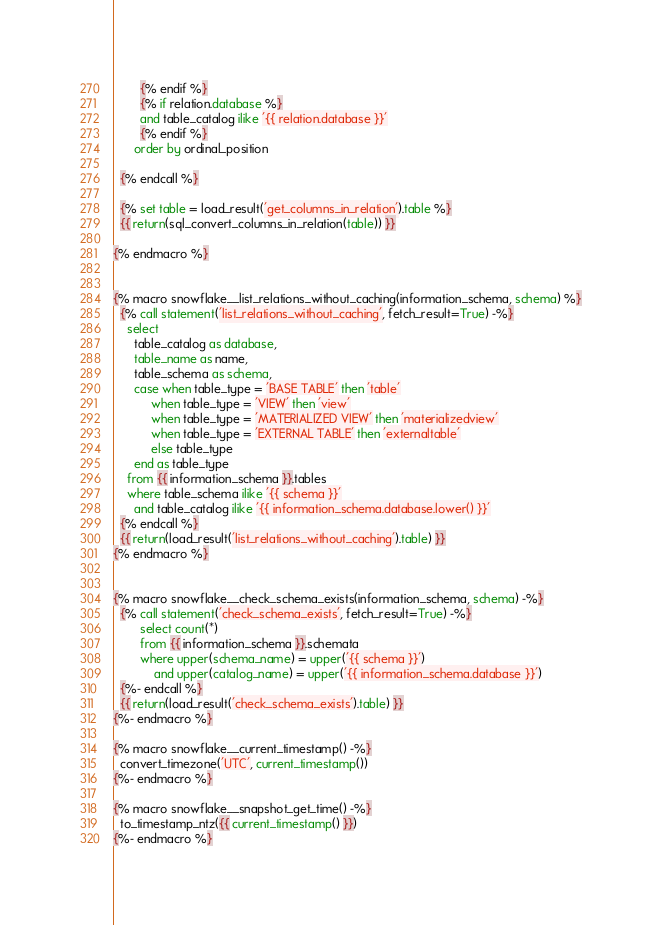Convert code to text. <code><loc_0><loc_0><loc_500><loc_500><_SQL_>        {% endif %}
        {% if relation.database %}
        and table_catalog ilike '{{ relation.database }}'
        {% endif %}
      order by ordinal_position

  {% endcall %}

  {% set table = load_result('get_columns_in_relation').table %}
  {{ return(sql_convert_columns_in_relation(table)) }}

{% endmacro %}


{% macro snowflake__list_relations_without_caching(information_schema, schema) %}
  {% call statement('list_relations_without_caching', fetch_result=True) -%}
    select
      table_catalog as database,
      table_name as name,
      table_schema as schema,
      case when table_type = 'BASE TABLE' then 'table'
           when table_type = 'VIEW' then 'view'
           when table_type = 'MATERIALIZED VIEW' then 'materializedview'
           when table_type = 'EXTERNAL TABLE' then 'externaltable'
           else table_type
      end as table_type
    from {{ information_schema }}.tables
    where table_schema ilike '{{ schema }}'
      and table_catalog ilike '{{ information_schema.database.lower() }}'
  {% endcall %}
  {{ return(load_result('list_relations_without_caching').table) }}
{% endmacro %}


{% macro snowflake__check_schema_exists(information_schema, schema) -%}
  {% call statement('check_schema_exists', fetch_result=True) -%}
        select count(*)
        from {{ information_schema }}.schemata
        where upper(schema_name) = upper('{{ schema }}')
            and upper(catalog_name) = upper('{{ information_schema.database }}')
  {%- endcall %}
  {{ return(load_result('check_schema_exists').table) }}
{%- endmacro %}

{% macro snowflake__current_timestamp() -%}
  convert_timezone('UTC', current_timestamp())
{%- endmacro %}

{% macro snowflake__snapshot_get_time() -%}
  to_timestamp_ntz({{ current_timestamp() }})
{%- endmacro %}

</code> 